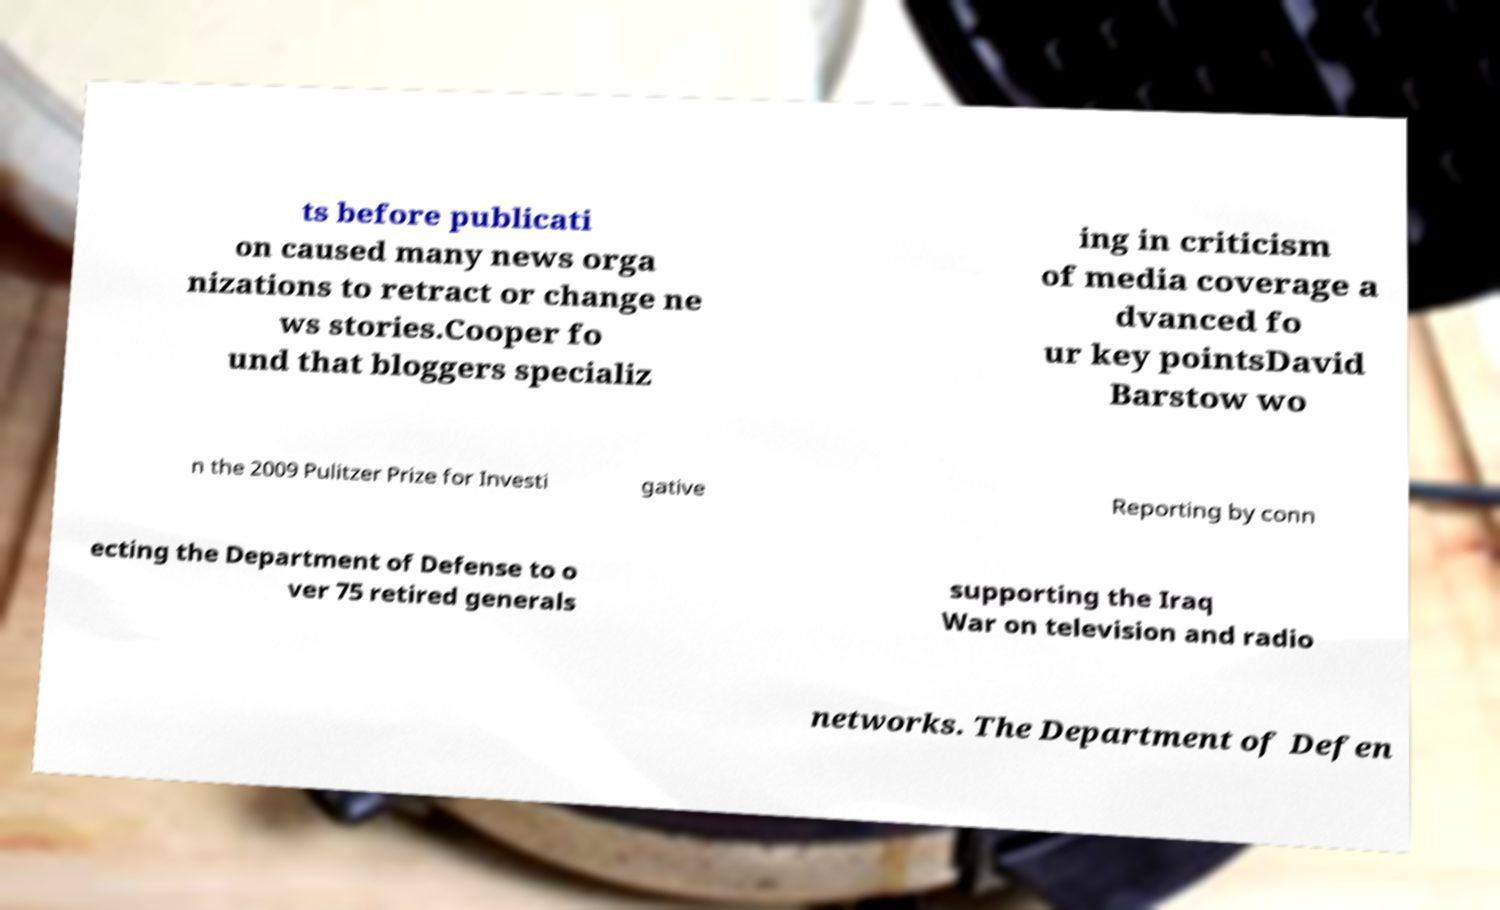For documentation purposes, I need the text within this image transcribed. Could you provide that? ts before publicati on caused many news orga nizations to retract or change ne ws stories.Cooper fo und that bloggers specializ ing in criticism of media coverage a dvanced fo ur key pointsDavid Barstow wo n the 2009 Pulitzer Prize for Investi gative Reporting by conn ecting the Department of Defense to o ver 75 retired generals supporting the Iraq War on television and radio networks. The Department of Defen 